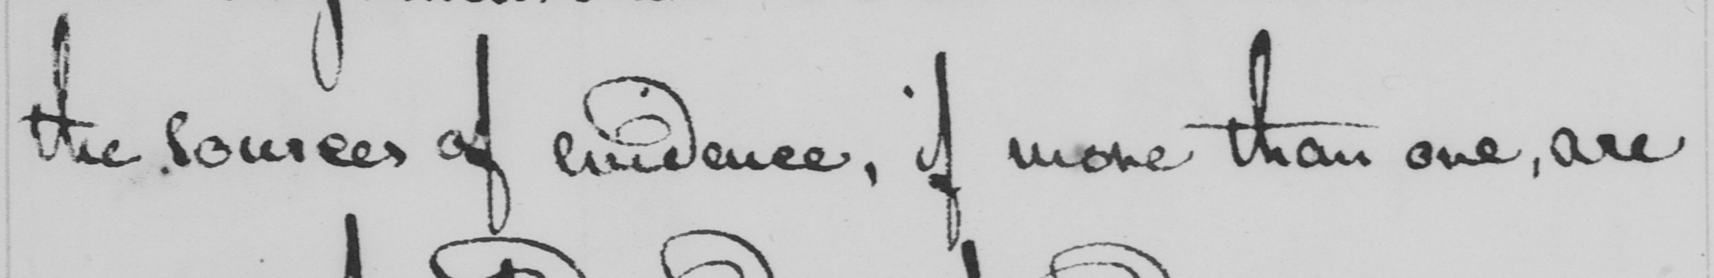Please transcribe the handwritten text in this image. the sources of evidence , if more than one , are 